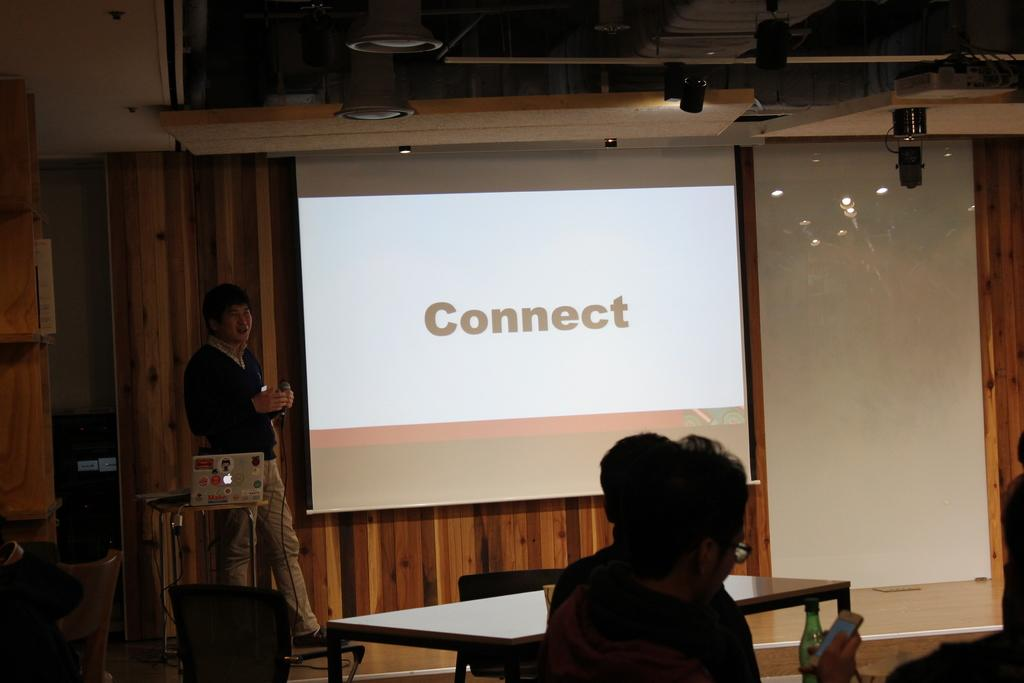How many people are in the image? There are three people in the image. What is one person doing in the image? One person is holding a microphone. What can be seen to the left of the person holding the microphone? There is a screen to the left of the person holding the microphone. Where is the drain located in the image? There is no drain present in the image. What type of store can be seen in the background of the image? There is no store visible in the image. 